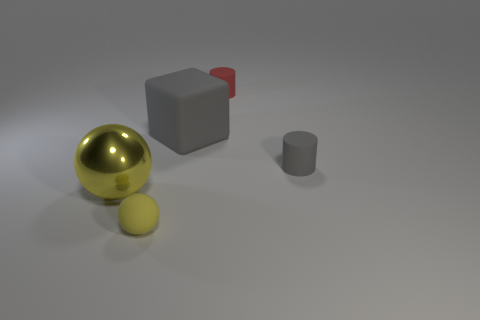Is the color of the small matte sphere the same as the large sphere?
Your answer should be compact. Yes. Is there anything else of the same color as the large metal ball?
Give a very brief answer. Yes. What number of gray rubber things are on the right side of the gray rubber thing that is to the left of the small rubber cylinder that is in front of the cube?
Provide a short and direct response. 1. Is the number of shiny balls less than the number of tiny cyan metal cylinders?
Offer a very short reply. No. There is a matte object on the right side of the red cylinder; does it have the same shape as the tiny rubber object behind the tiny gray thing?
Provide a short and direct response. Yes. The shiny thing has what color?
Give a very brief answer. Yellow. How many metal objects are tiny gray objects or small yellow things?
Offer a very short reply. 0. What is the color of the other matte thing that is the same shape as the tiny red thing?
Offer a very short reply. Gray. Are there any green rubber spheres?
Provide a short and direct response. No. Are the cylinder behind the gray rubber block and the large thing in front of the matte cube made of the same material?
Your response must be concise. No. 